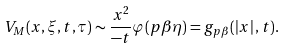<formula> <loc_0><loc_0><loc_500><loc_500>V _ { M } ( x , \xi , t , \tau ) \sim \frac { x ^ { 2 } } { - t } \varphi ( p \beta \eta ) = g _ { p \beta } ( \left | x \right | , t ) .</formula> 